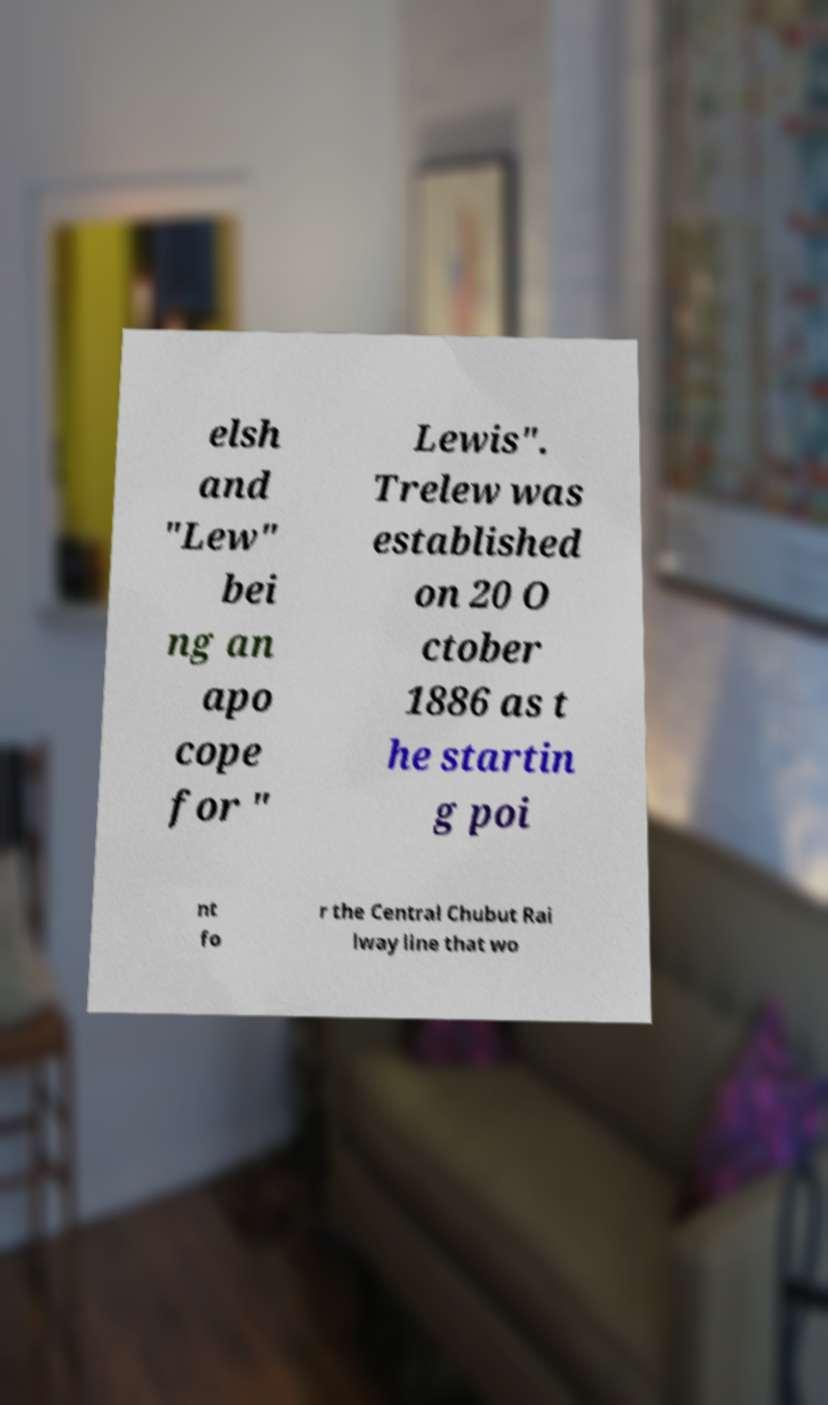Please identify and transcribe the text found in this image. elsh and "Lew" bei ng an apo cope for " Lewis". Trelew was established on 20 O ctober 1886 as t he startin g poi nt fo r the Central Chubut Rai lway line that wo 